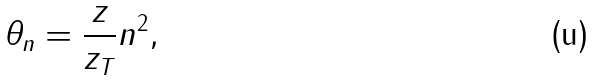<formula> <loc_0><loc_0><loc_500><loc_500>\theta _ { n } = \frac { z } { z _ { T } } n ^ { 2 } ,</formula> 